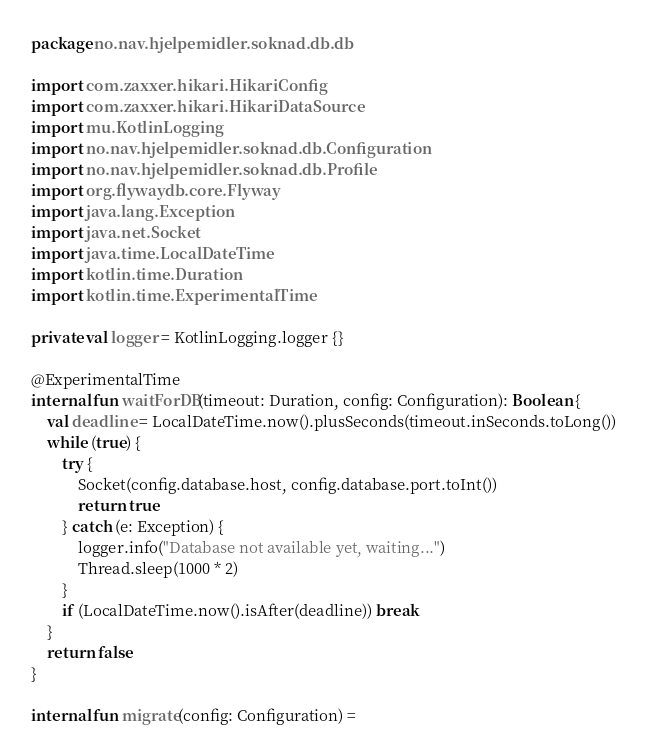<code> <loc_0><loc_0><loc_500><loc_500><_Kotlin_>package no.nav.hjelpemidler.soknad.db.db

import com.zaxxer.hikari.HikariConfig
import com.zaxxer.hikari.HikariDataSource
import mu.KotlinLogging
import no.nav.hjelpemidler.soknad.db.Configuration
import no.nav.hjelpemidler.soknad.db.Profile
import org.flywaydb.core.Flyway
import java.lang.Exception
import java.net.Socket
import java.time.LocalDateTime
import kotlin.time.Duration
import kotlin.time.ExperimentalTime

private val logger = KotlinLogging.logger {}

@ExperimentalTime
internal fun waitForDB(timeout: Duration, config: Configuration): Boolean {
    val deadline = LocalDateTime.now().plusSeconds(timeout.inSeconds.toLong())
    while (true) {
        try {
            Socket(config.database.host, config.database.port.toInt())
            return true
        } catch (e: Exception) {
            logger.info("Database not available yet, waiting...")
            Thread.sleep(1000 * 2)
        }
        if (LocalDateTime.now().isAfter(deadline)) break
    }
    return false
}

internal fun migrate(config: Configuration) =</code> 